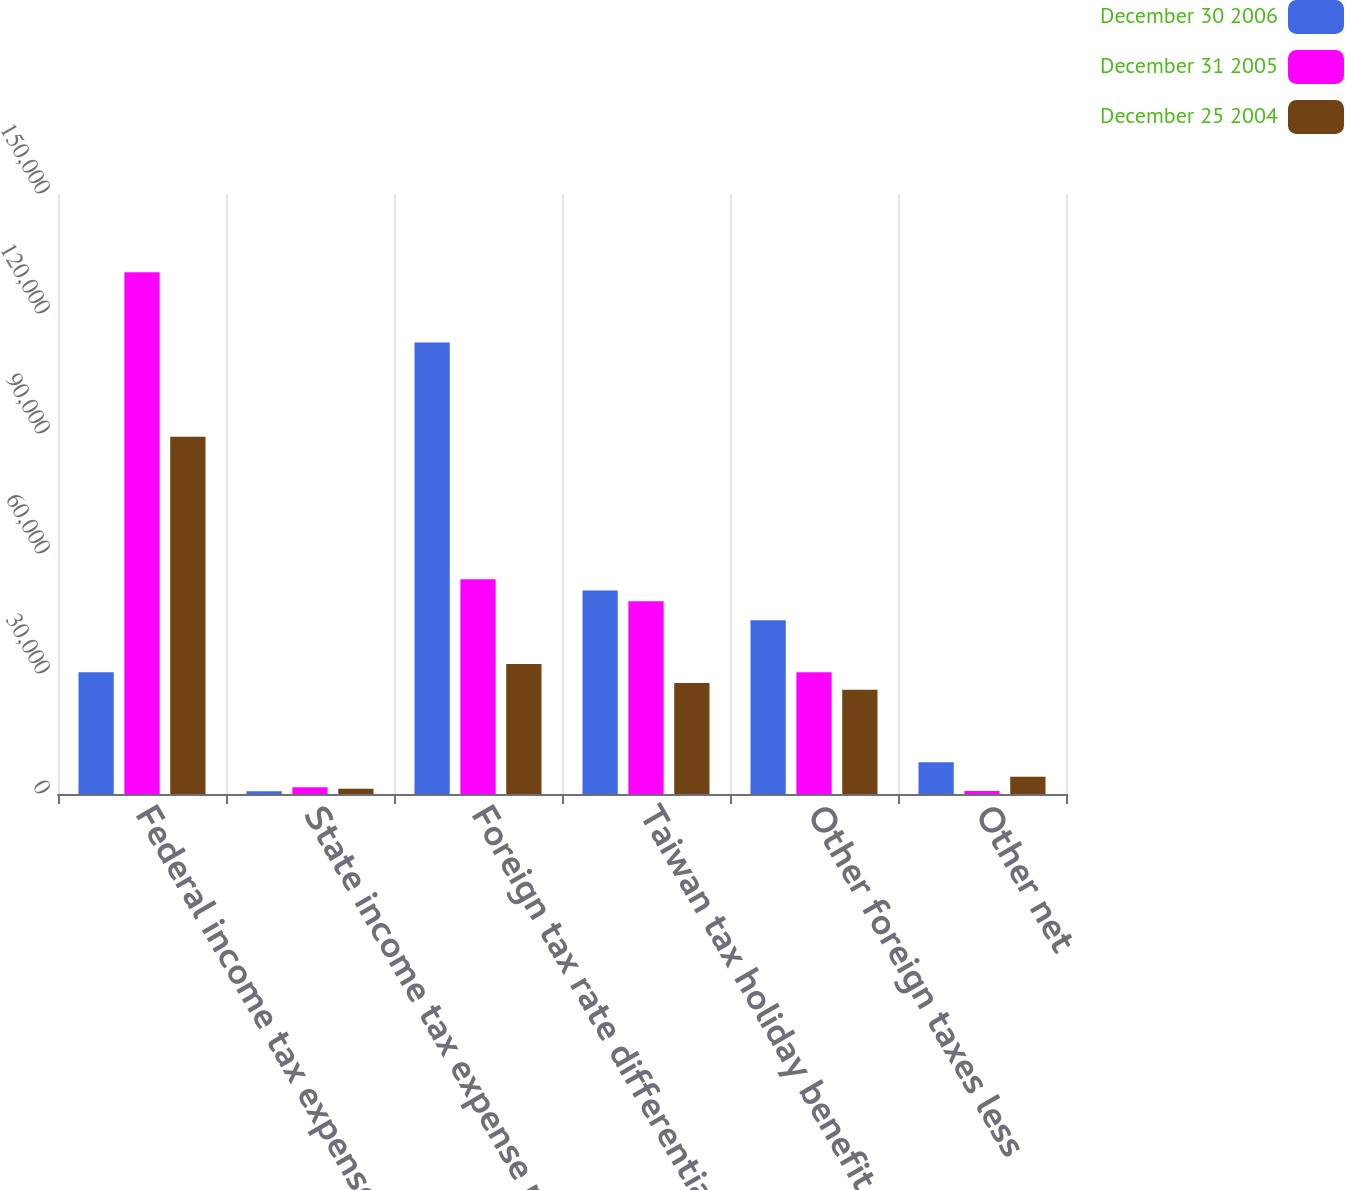Convert chart. <chart><loc_0><loc_0><loc_500><loc_500><stacked_bar_chart><ecel><fcel>Federal income tax expense at<fcel>State income tax expense net<fcel>Foreign tax rate differential<fcel>Taiwan tax holiday benefit<fcel>Other foreign taxes less<fcel>Other net<nl><fcel>December 30 2006<fcel>30427<fcel>658<fcel>112903<fcel>50905<fcel>43445<fcel>7958<nl><fcel>December 31 2005<fcel>130410<fcel>1666<fcel>53712<fcel>48175<fcel>30427<fcel>765<nl><fcel>December 25 2004<fcel>89324<fcel>1303<fcel>32516<fcel>27753<fcel>26080<fcel>4321<nl></chart> 